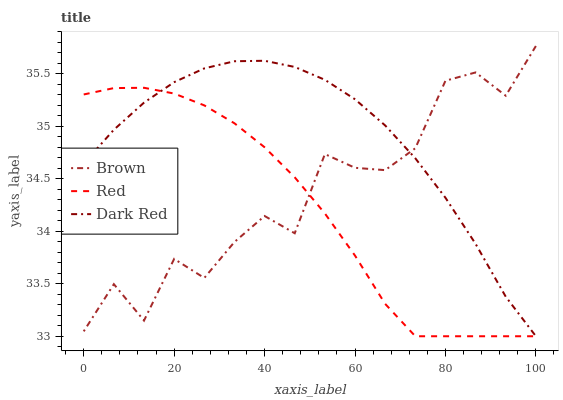Does Red have the minimum area under the curve?
Answer yes or no. Yes. Does Dark Red have the maximum area under the curve?
Answer yes or no. Yes. Does Dark Red have the minimum area under the curve?
Answer yes or no. No. Does Red have the maximum area under the curve?
Answer yes or no. No. Is Dark Red the smoothest?
Answer yes or no. Yes. Is Brown the roughest?
Answer yes or no. Yes. Is Red the smoothest?
Answer yes or no. No. Is Red the roughest?
Answer yes or no. No. Does Red have the lowest value?
Answer yes or no. Yes. Does Brown have the highest value?
Answer yes or no. Yes. Does Dark Red have the highest value?
Answer yes or no. No. Does Dark Red intersect Brown?
Answer yes or no. Yes. Is Dark Red less than Brown?
Answer yes or no. No. Is Dark Red greater than Brown?
Answer yes or no. No. 